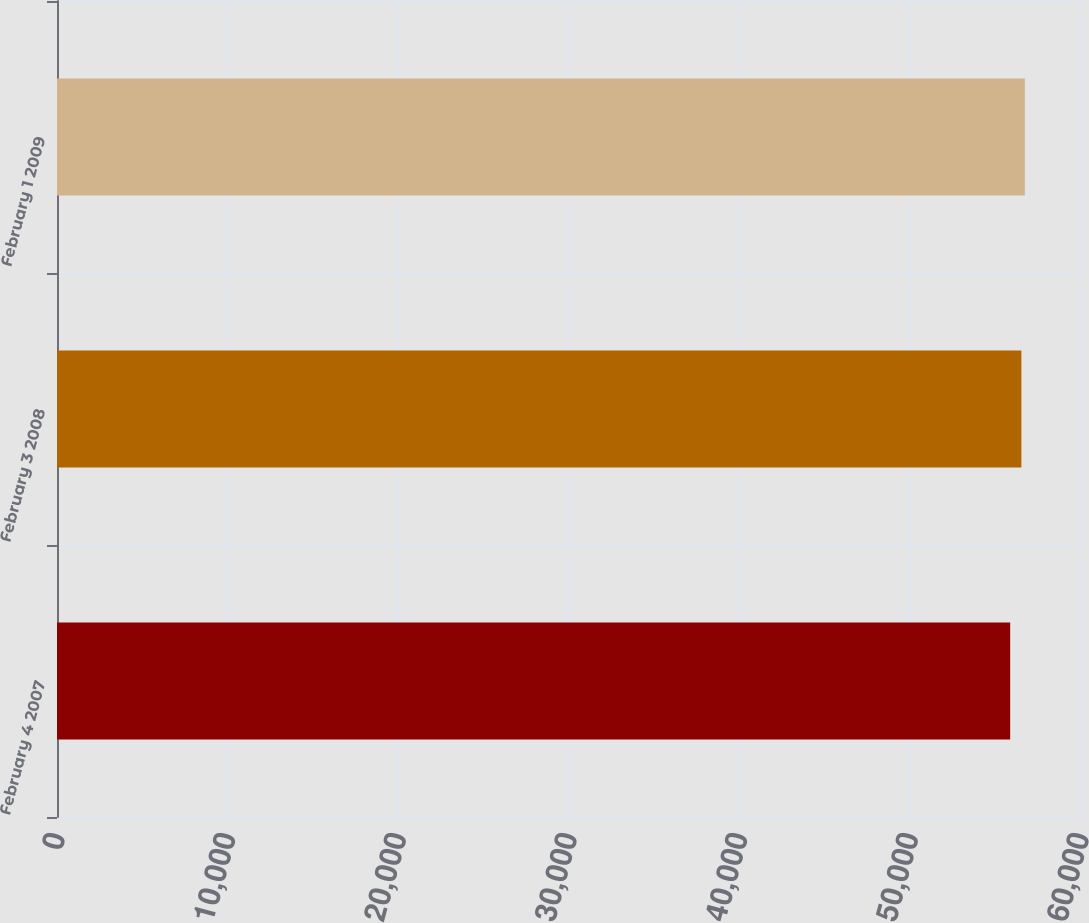Convert chart. <chart><loc_0><loc_0><loc_500><loc_500><bar_chart><fcel>February 4 2007<fcel>February 3 2008<fcel>February 1 2009<nl><fcel>55850<fcel>56506<fcel>56709<nl></chart> 